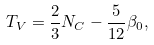Convert formula to latex. <formula><loc_0><loc_0><loc_500><loc_500>T _ { V } = \frac { 2 } { 3 } N _ { C } - \frac { 5 } { 1 2 } \beta _ { 0 } ,</formula> 